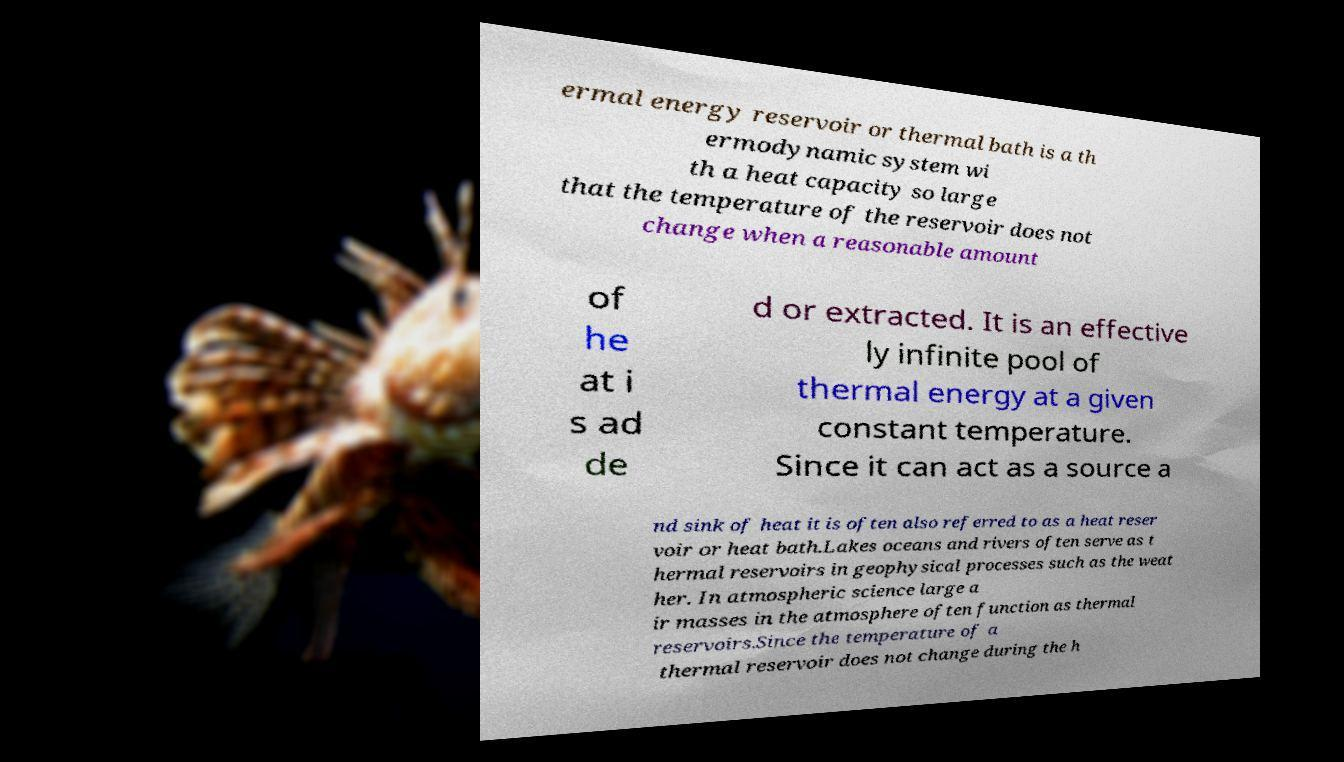Please identify and transcribe the text found in this image. ermal energy reservoir or thermal bath is a th ermodynamic system wi th a heat capacity so large that the temperature of the reservoir does not change when a reasonable amount of he at i s ad de d or extracted. It is an effective ly infinite pool of thermal energy at a given constant temperature. Since it can act as a source a nd sink of heat it is often also referred to as a heat reser voir or heat bath.Lakes oceans and rivers often serve as t hermal reservoirs in geophysical processes such as the weat her. In atmospheric science large a ir masses in the atmosphere often function as thermal reservoirs.Since the temperature of a thermal reservoir does not change during the h 